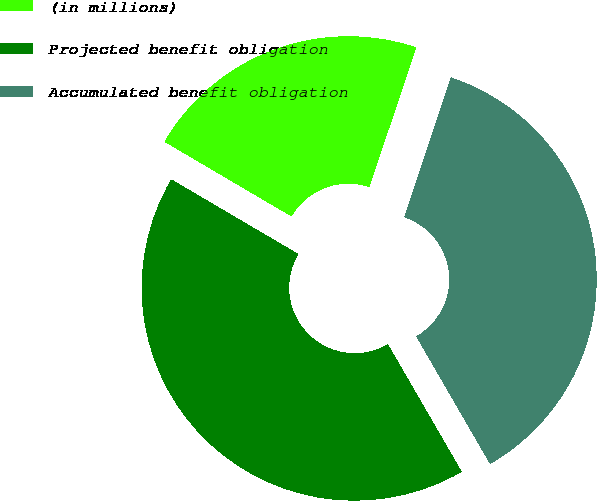Convert chart. <chart><loc_0><loc_0><loc_500><loc_500><pie_chart><fcel>(in millions)<fcel>Projected benefit obligation<fcel>Accumulated benefit obligation<nl><fcel>21.67%<fcel>41.81%<fcel>36.52%<nl></chart> 